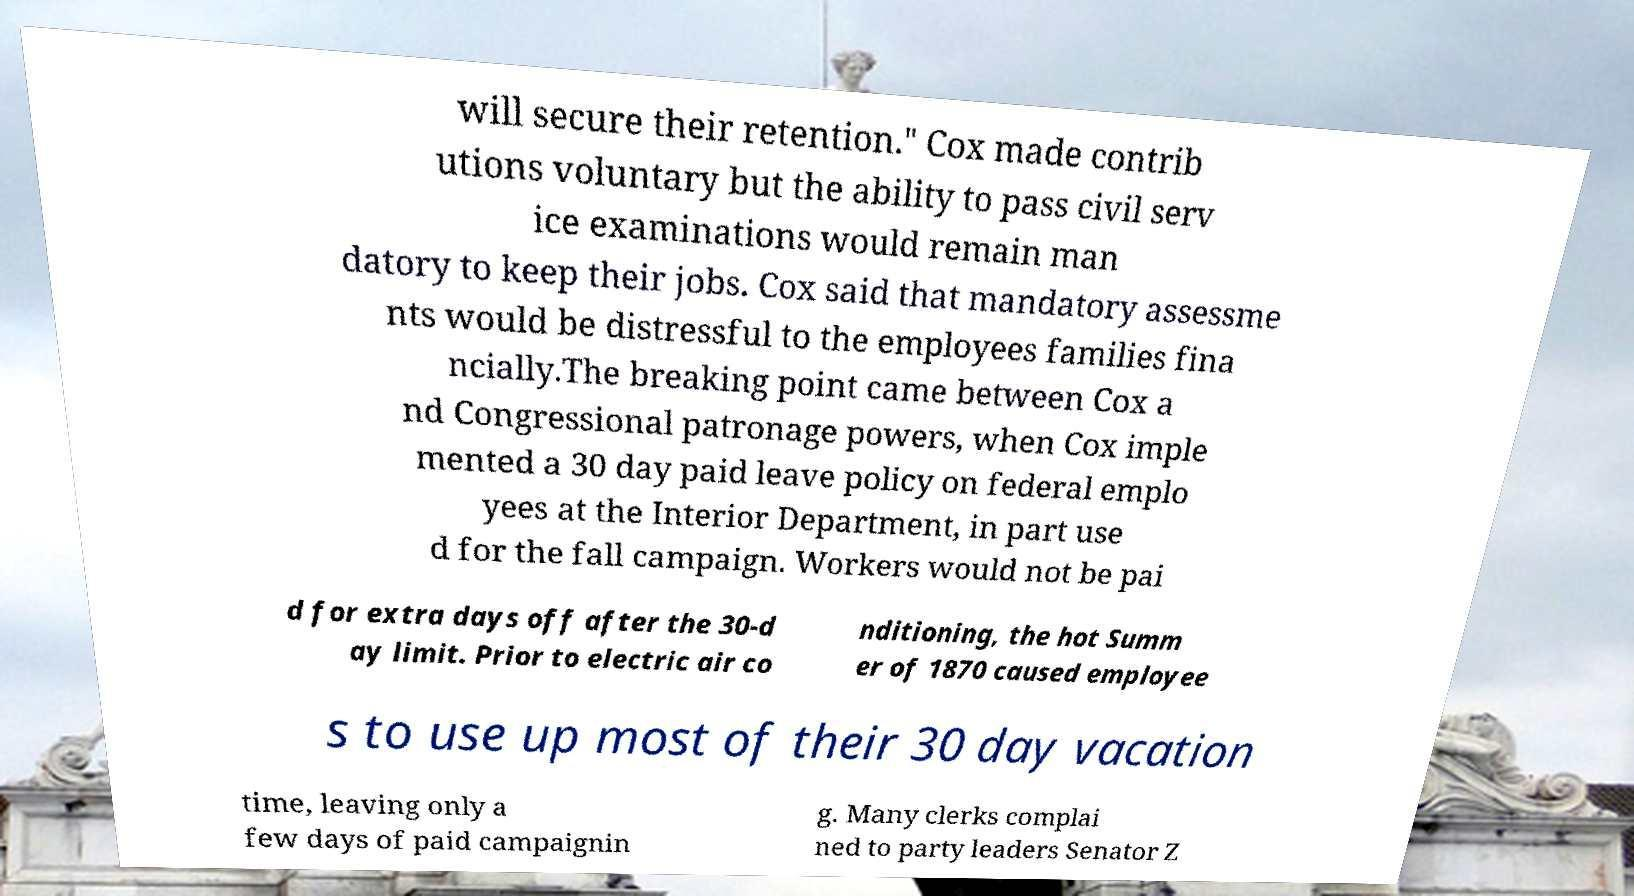There's text embedded in this image that I need extracted. Can you transcribe it verbatim? will secure their retention." Cox made contrib utions voluntary but the ability to pass civil serv ice examinations would remain man datory to keep their jobs. Cox said that mandatory assessme nts would be distressful to the employees families fina ncially.The breaking point came between Cox a nd Congressional patronage powers, when Cox imple mented a 30 day paid leave policy on federal emplo yees at the Interior Department, in part use d for the fall campaign. Workers would not be pai d for extra days off after the 30-d ay limit. Prior to electric air co nditioning, the hot Summ er of 1870 caused employee s to use up most of their 30 day vacation time, leaving only a few days of paid campaignin g. Many clerks complai ned to party leaders Senator Z 